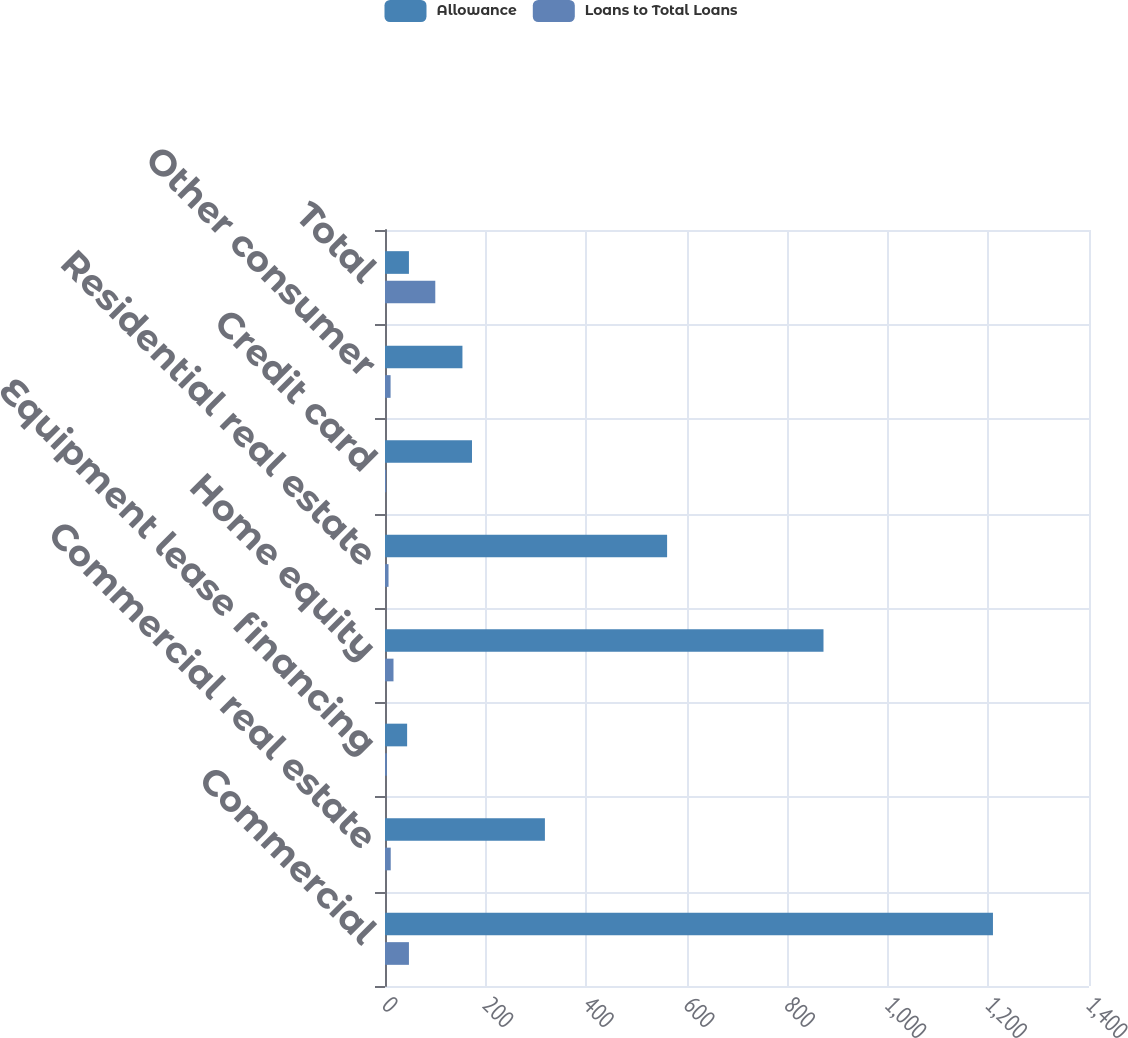Convert chart. <chart><loc_0><loc_0><loc_500><loc_500><stacked_bar_chart><ecel><fcel>Commercial<fcel>Commercial real estate<fcel>Equipment lease financing<fcel>Home equity<fcel>Residential real estate<fcel>Credit card<fcel>Other consumer<fcel>Total<nl><fcel>Allowance<fcel>1209<fcel>318<fcel>44<fcel>872<fcel>561<fcel>173<fcel>154<fcel>47.6<nl><fcel>Loans to Total Loans<fcel>47.6<fcel>11.4<fcel>3.7<fcel>16.9<fcel>7<fcel>2.3<fcel>11.1<fcel>100<nl></chart> 